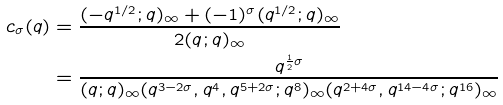<formula> <loc_0><loc_0><loc_500><loc_500>c _ { \sigma } ( q ) & = \frac { ( - q ^ { 1 / 2 } ; q ) _ { \infty } + ( - 1 ) ^ { \sigma } ( q ^ { 1 / 2 } ; q ) _ { \infty } } { 2 ( q ; q ) _ { \infty } } \\ & = \frac { q ^ { \frac { 1 } { 2 } \sigma } } { ( q ; q ) _ { \infty } ( q ^ { 3 - 2 \sigma } , q ^ { 4 } , q ^ { 5 + 2 \sigma } ; q ^ { 8 } ) _ { \infty } ( q ^ { 2 + 4 \sigma } , q ^ { 1 4 - 4 \sigma } ; q ^ { 1 6 } ) _ { \infty } }</formula> 